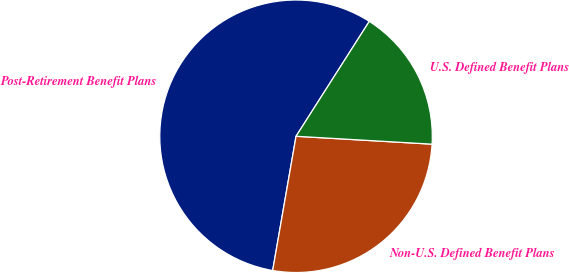Convert chart to OTSL. <chart><loc_0><loc_0><loc_500><loc_500><pie_chart><fcel>Post-Retirement Benefit Plans<fcel>Non-U.S. Defined Benefit Plans<fcel>U.S. Defined Benefit Plans<nl><fcel>56.29%<fcel>26.82%<fcel>16.89%<nl></chart> 